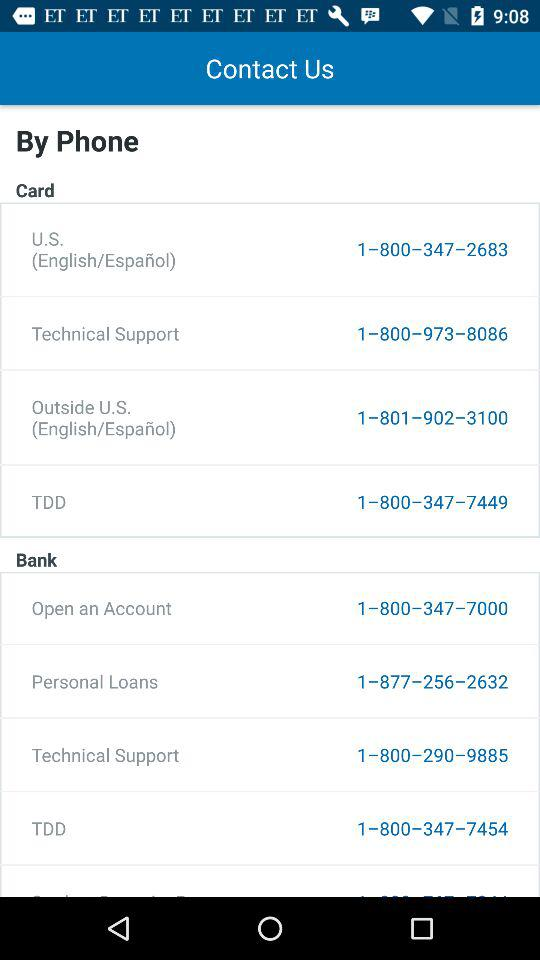What is the contact number to open an account in the bank? The contact number is 1–800–347–7000. 